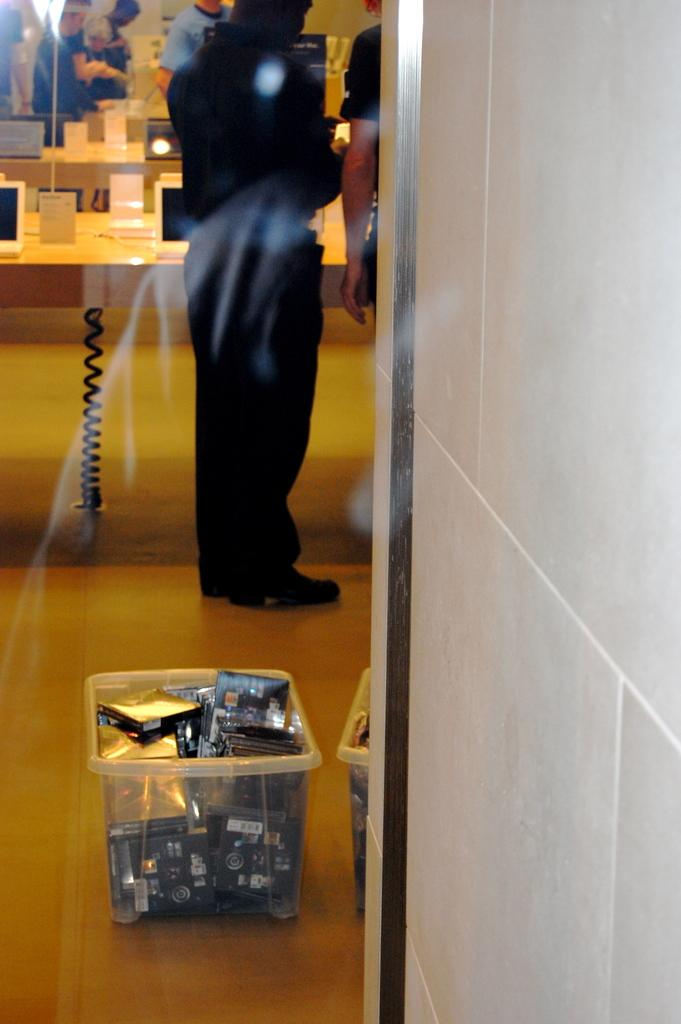What is contained within the baskets in the image? There are objects in baskets in the image. What type of electronic devices can be seen in the image? There are laptops visible in the image. What type of flat surfaces are present in the image? There are boards and tables in the image. What can be observed about the people in the image? There are people standing in the image. Are there any stockings visible in the image? There is no mention of stockings in the provided facts, so we cannot determine if they are present in the image. What level of difficulty is indicated by the chalk on the board in the image? There is no chalk or board present in the image, so we cannot determine the level of difficulty for any activity. 